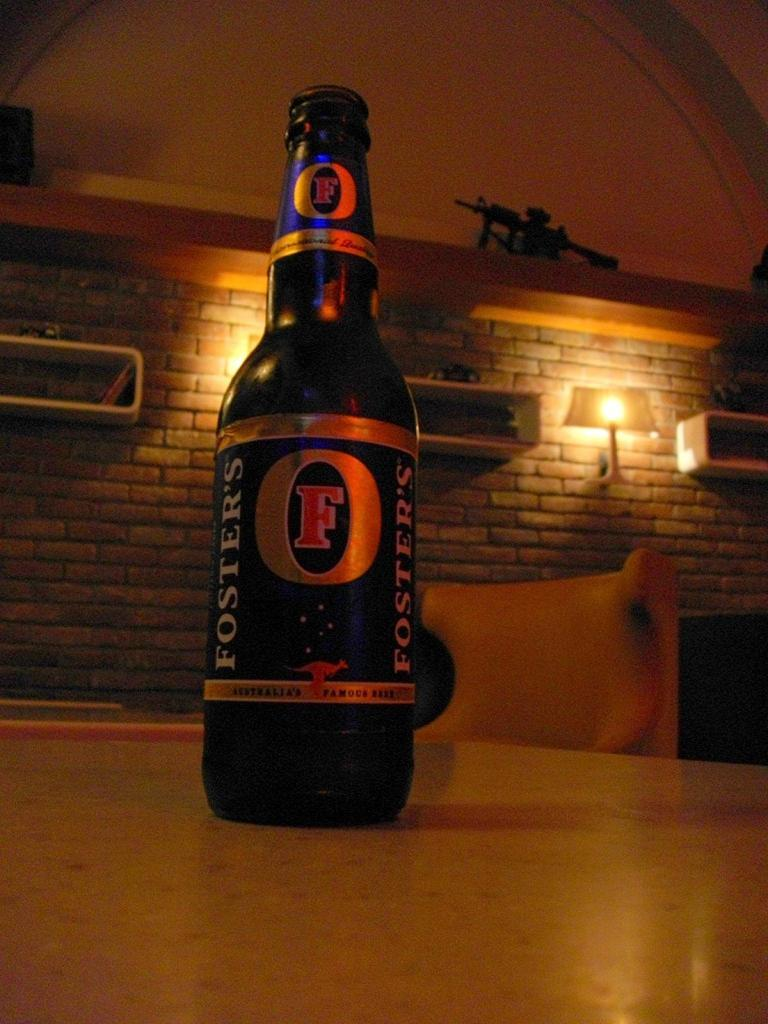<image>
Relay a brief, clear account of the picture shown. A bottle of Fosters beer sitting on a dinning room table. 